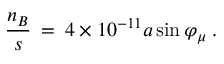<formula> <loc_0><loc_0><loc_500><loc_500>\frac { n _ { B } } { s } \, = \, 4 \times 1 0 ^ { - 1 1 } a \sin \varphi _ { \mu } \, .</formula> 